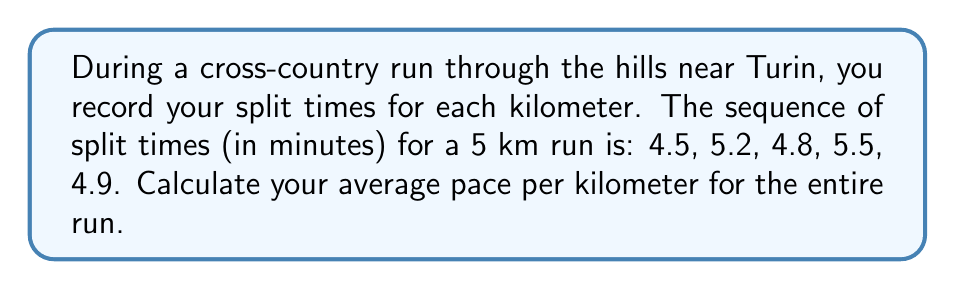Can you answer this question? To calculate the average pace per kilometer, we need to follow these steps:

1. Sum up all the split times:
   $$4.5 + 5.2 + 4.8 + 5.5 + 4.9 = 24.9 \text{ minutes}$$

2. Divide the total time by the number of kilometers to get the average pace:
   $$\text{Average Pace} = \frac{\text{Total Time}}{\text{Total Distance}}$$
   $$\text{Average Pace} = \frac{24.9 \text{ minutes}}{5 \text{ km}} = 4.98 \text{ minutes/km}$$

3. Convert the decimal portion to seconds:
   $$0.98 \times 60 \text{ seconds} = 58.8 \text{ seconds}$$

Therefore, the average pace is 4 minutes and 59 seconds per kilometer (rounding to the nearest second).
Answer: 4:59 min/km 